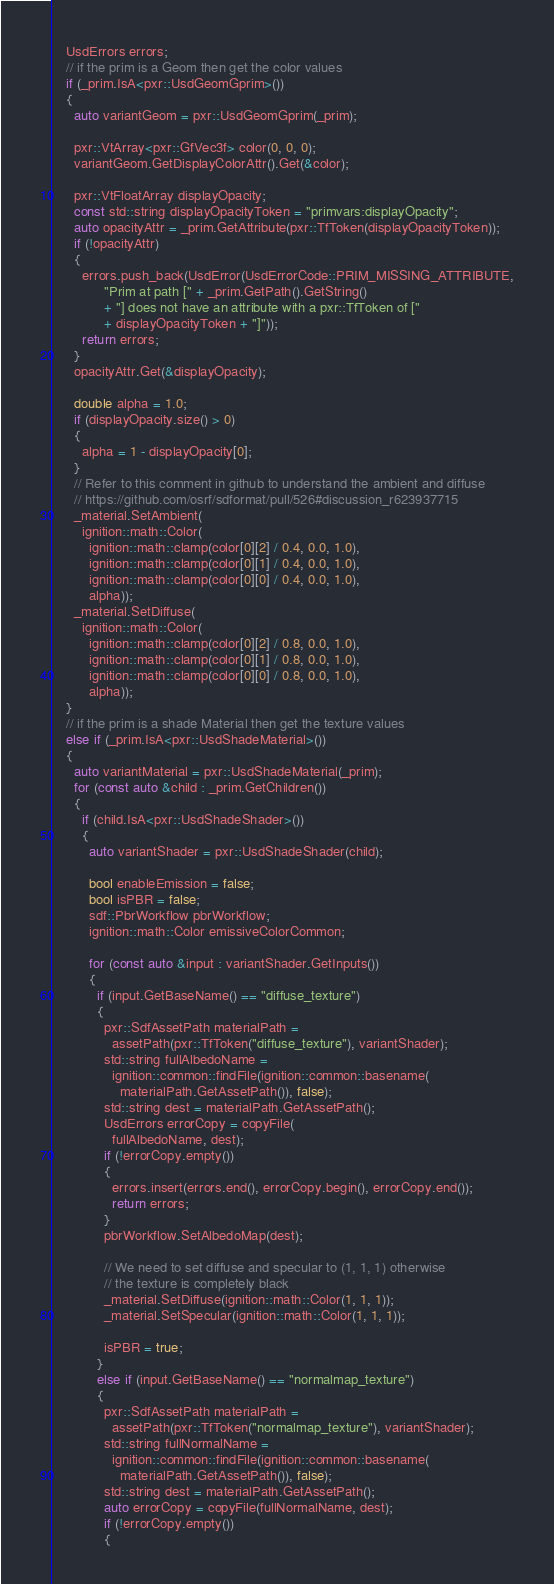Convert code to text. <code><loc_0><loc_0><loc_500><loc_500><_C++_>    UsdErrors errors;
    // if the prim is a Geom then get the color values
    if (_prim.IsA<pxr::UsdGeomGprim>())
    {
      auto variantGeom = pxr::UsdGeomGprim(_prim);

      pxr::VtArray<pxr::GfVec3f> color(0, 0, 0);
      variantGeom.GetDisplayColorAttr().Get(&color);

      pxr::VtFloatArray displayOpacity;
      const std::string displayOpacityToken = "primvars:displayOpacity";
      auto opacityAttr = _prim.GetAttribute(pxr::TfToken(displayOpacityToken));
      if (!opacityAttr)
      {
        errors.push_back(UsdError(UsdErrorCode::PRIM_MISSING_ATTRIBUTE,
              "Prim at path [" + _prim.GetPath().GetString()
              + "] does not have an attribute with a pxr::TfToken of ["
              + displayOpacityToken + "]"));
        return errors;
      }
      opacityAttr.Get(&displayOpacity);

      double alpha = 1.0;
      if (displayOpacity.size() > 0)
      {
        alpha = 1 - displayOpacity[0];
      }
      // Refer to this comment in github to understand the ambient and diffuse
      // https://github.com/osrf/sdformat/pull/526#discussion_r623937715
      _material.SetAmbient(
        ignition::math::Color(
          ignition::math::clamp(color[0][2] / 0.4, 0.0, 1.0),
          ignition::math::clamp(color[0][1] / 0.4, 0.0, 1.0),
          ignition::math::clamp(color[0][0] / 0.4, 0.0, 1.0),
          alpha));
      _material.SetDiffuse(
        ignition::math::Color(
          ignition::math::clamp(color[0][2] / 0.8, 0.0, 1.0),
          ignition::math::clamp(color[0][1] / 0.8, 0.0, 1.0),
          ignition::math::clamp(color[0][0] / 0.8, 0.0, 1.0),
          alpha));
    }
    // if the prim is a shade Material then get the texture values
    else if (_prim.IsA<pxr::UsdShadeMaterial>())
    {
      auto variantMaterial = pxr::UsdShadeMaterial(_prim);
      for (const auto &child : _prim.GetChildren())
      {
        if (child.IsA<pxr::UsdShadeShader>())
        {
          auto variantShader = pxr::UsdShadeShader(child);

          bool enableEmission = false;
          bool isPBR = false;
          sdf::PbrWorkflow pbrWorkflow;
          ignition::math::Color emissiveColorCommon;

          for (const auto &input : variantShader.GetInputs())
          {
            if (input.GetBaseName() == "diffuse_texture")
            {
              pxr::SdfAssetPath materialPath =
                assetPath(pxr::TfToken("diffuse_texture"), variantShader);
              std::string fullAlbedoName =
                ignition::common::findFile(ignition::common::basename(
                  materialPath.GetAssetPath()), false);
              std::string dest = materialPath.GetAssetPath();
              UsdErrors errorCopy = copyFile(
                fullAlbedoName, dest);
              if (!errorCopy.empty())
              {
                errors.insert(errors.end(), errorCopy.begin(), errorCopy.end());
                return errors;
              }
              pbrWorkflow.SetAlbedoMap(dest);

              // We need to set diffuse and specular to (1, 1, 1) otherwise
              // the texture is completely black
              _material.SetDiffuse(ignition::math::Color(1, 1, 1));
              _material.SetSpecular(ignition::math::Color(1, 1, 1));

              isPBR = true;
            }
            else if (input.GetBaseName() == "normalmap_texture")
            {
              pxr::SdfAssetPath materialPath =
                assetPath(pxr::TfToken("normalmap_texture"), variantShader);
              std::string fullNormalName =
                ignition::common::findFile(ignition::common::basename(
                  materialPath.GetAssetPath()), false);
              std::string dest = materialPath.GetAssetPath();
              auto errorCopy = copyFile(fullNormalName, dest);
              if (!errorCopy.empty())
              {</code> 